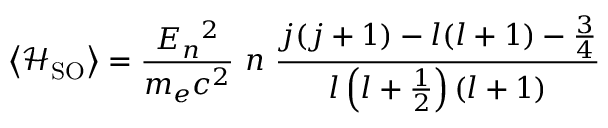<formula> <loc_0><loc_0><loc_500><loc_500>\left \langle { \mathcal { H } } _ { S O } \right \rangle = { \frac { E _ { n ^ { 2 } } { m _ { e } c ^ { 2 } } } n { \frac { j ( j + 1 ) - l ( l + 1 ) - { \frac { 3 } { 4 } } } { l \left ( l + { \frac { 1 } { 2 } } \right ) ( l + 1 ) } }</formula> 